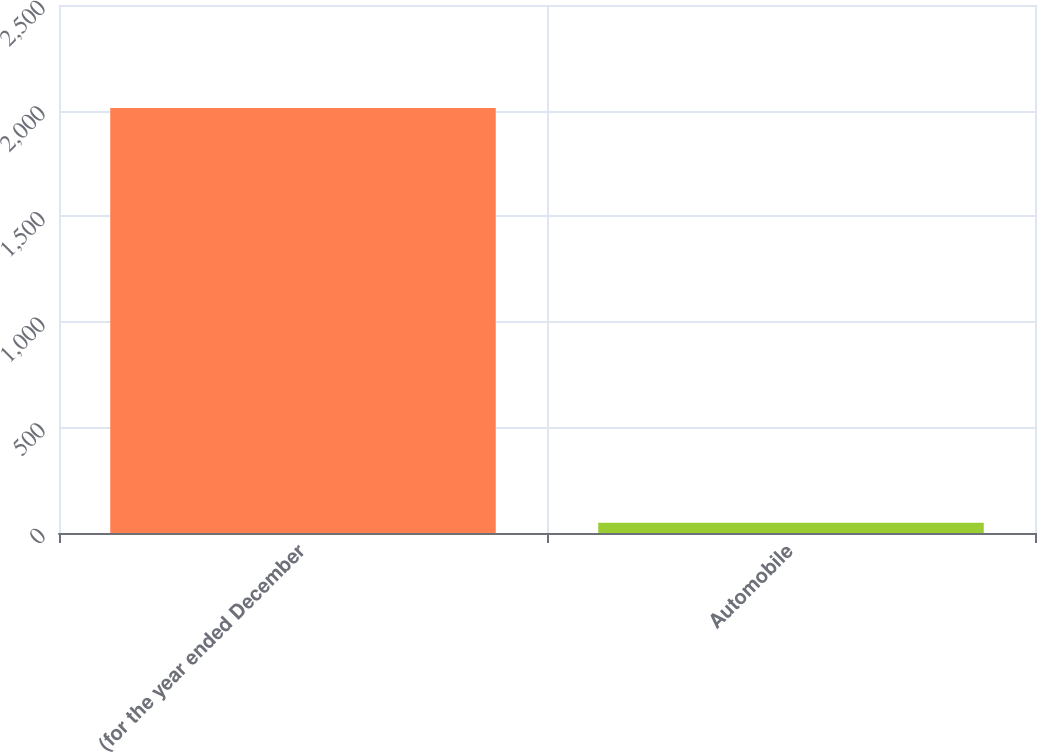Convert chart. <chart><loc_0><loc_0><loc_500><loc_500><bar_chart><fcel>(for the year ended December<fcel>Automobile<nl><fcel>2012<fcel>48<nl></chart> 